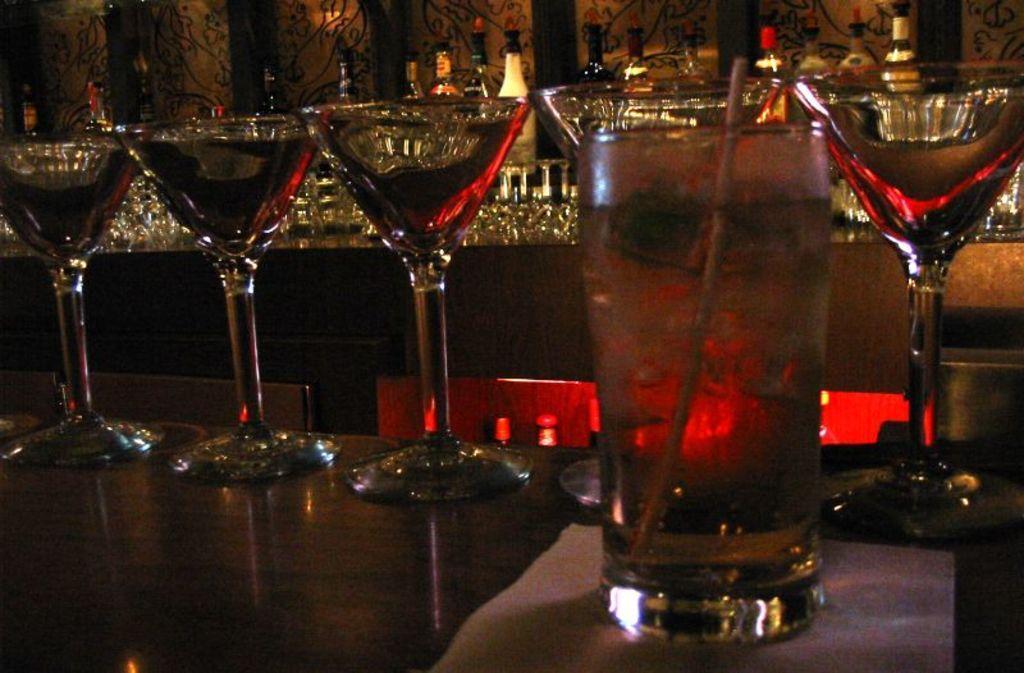How would you summarize this image in a sentence or two? There are glasses filled with drinks arranged on a table on which there is a glass filled with juice on a white paper. In the background, there are glasses arranged on a table and there are bottles in a shelf. 